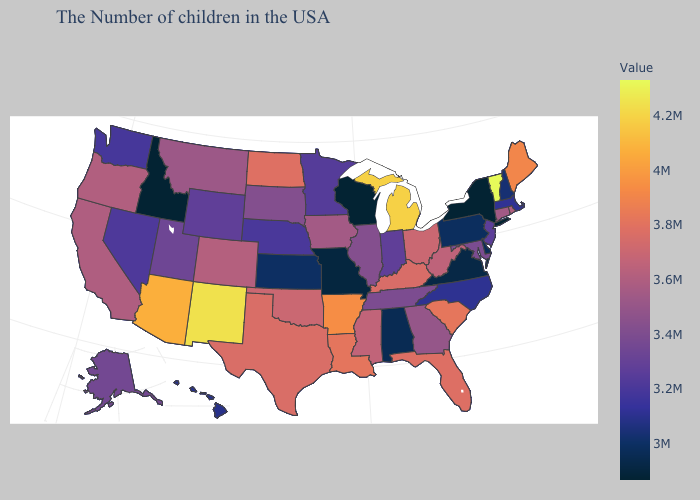Among the states that border New York , does Pennsylvania have the lowest value?
Be succinct. Yes. Which states have the lowest value in the West?
Answer briefly. Idaho. Among the states that border Oregon , does Washington have the lowest value?
Quick response, please. No. Which states have the lowest value in the West?
Short answer required. Idaho. 